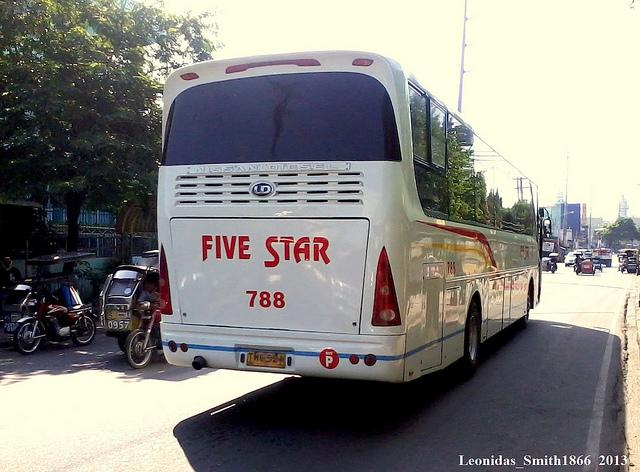What letter is on the bumper? letter p 